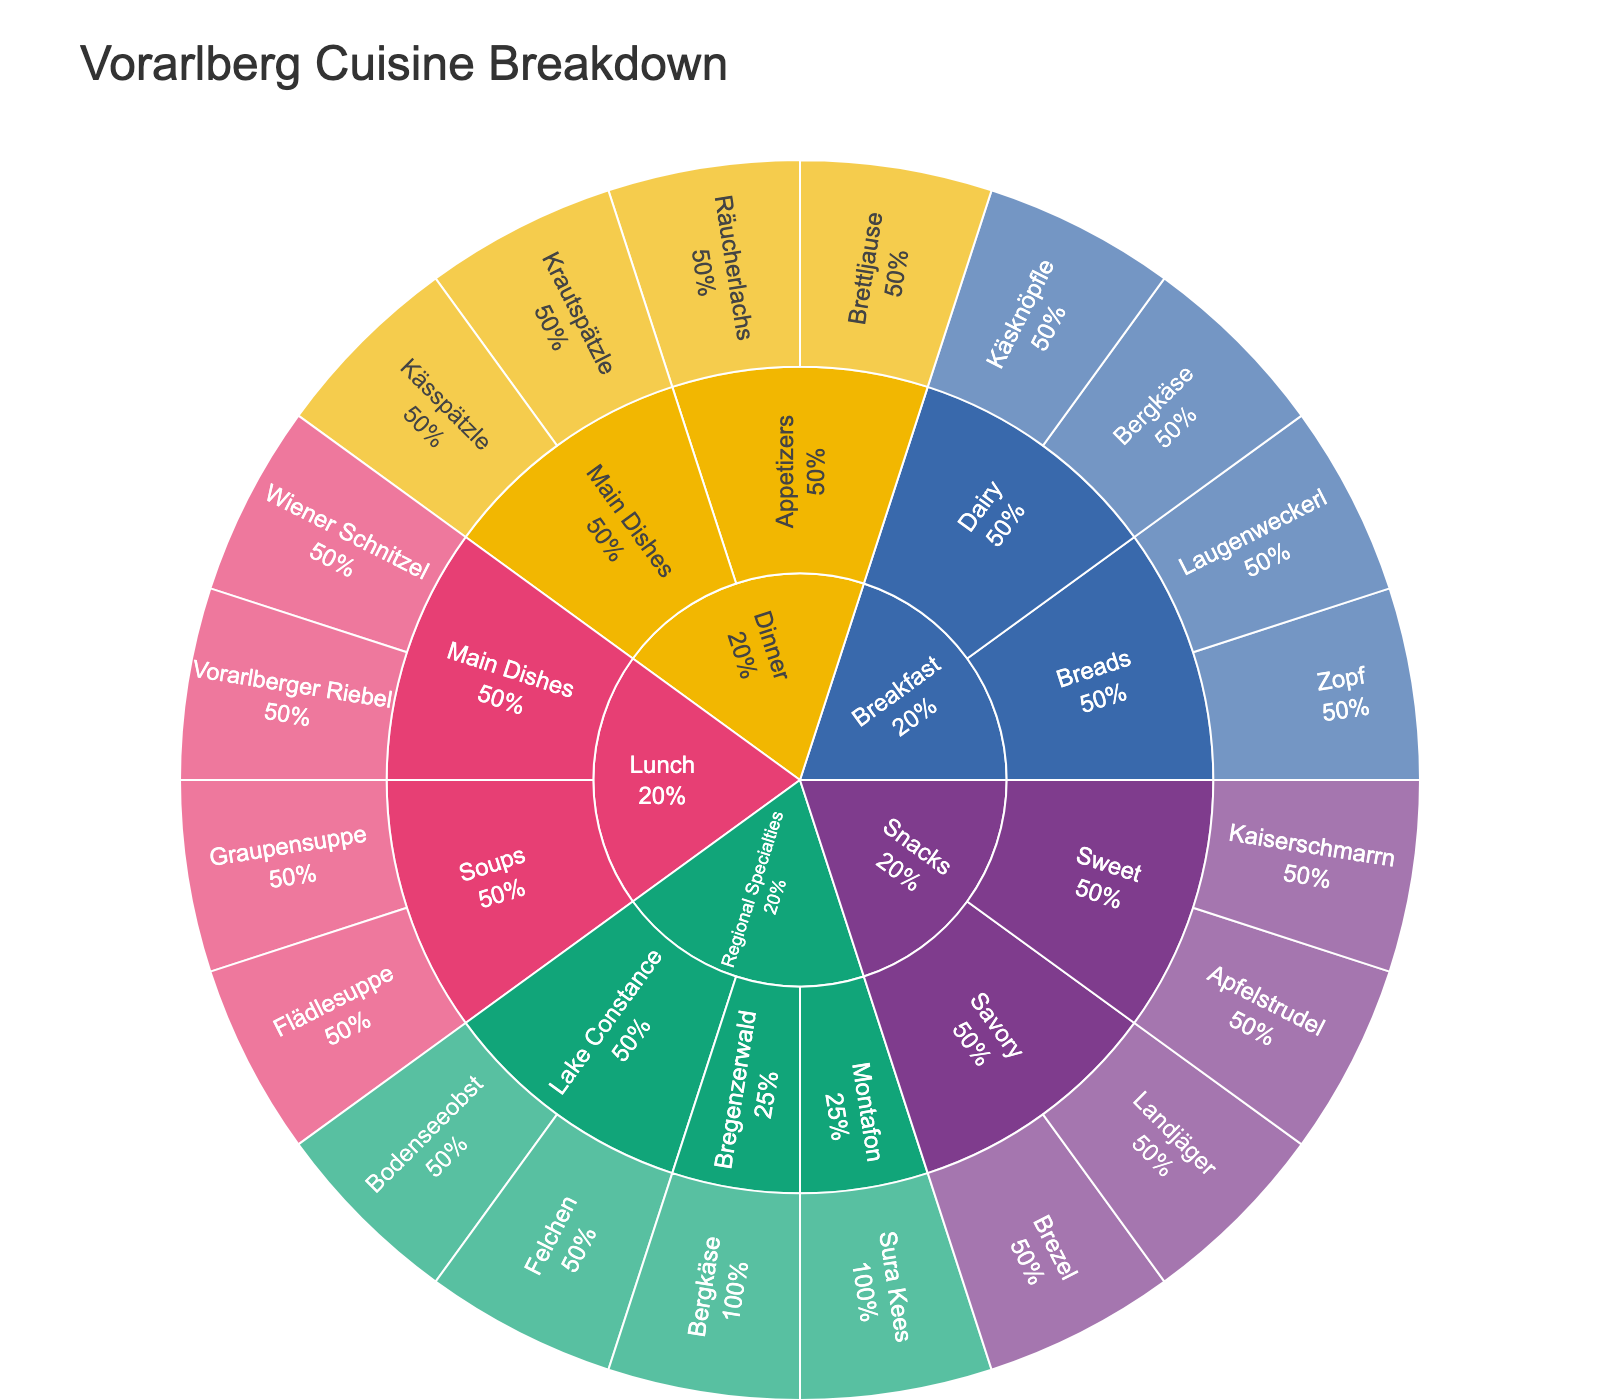what is the title of the figure? The title can be found at the top of the figure, and it is displayed as "Vorarlberg Cuisine Breakdown".
Answer: "Vorarlberg Cuisine Breakdown" Which meal type has the most dishes? By looking at the length of the branches in the sunburst plot, we can see that "Lunch" has the most dishes.
Answer: Lunch Which breakfast dish uses dairy as the main ingredient? By following the breakfast branch and then the dairy category, we can identify the dishes under this category.
Answer: Käsknöpfle, Bergkäse What proportion of the overall plot does "Sweet" snacks category represent in the snack section? By observing the segment for snacks and noting the portion of the "Sweet" subcategory, we can estimate the proportion it represents out of the snack section.
Answer: 50% Compare the number of dishes in the "Main Dishes" category for Lunch and Dinner. Which has more? There are two main dishes for Lunch (Wiener Schnitzel, Vorarlberger Riebel) and also two for Dinner (Kässpätzle, Krautspätzle), making them equal.
Answer: They are equal Which regional specialty belongs to the Montafon? By navigating through the regional specialties category and finding Montafon, we identify the dish linked to that region.
Answer: Sura Kees What is the main ingredient category for Apfelstrudel? We locate Apfelstrudel under the snacks section and see that it falls under the "Sweet" category.
Answer: Sweet Can you identify two dishes that are made from main dishes for Dinner? Following the dinner branch and then the main dishes category, we can spot the two dishes listed there.
Answer: Kässpätzle, Krautspätzle How many total dishes are listed under "Breakfast"? By counting each dish listed under the breakfast sections for all categories, we sum up all of them. 4 in total, Käsknöpfle, Bergkäse, Zopf, and Laugenweckerl.
Answer: 4 